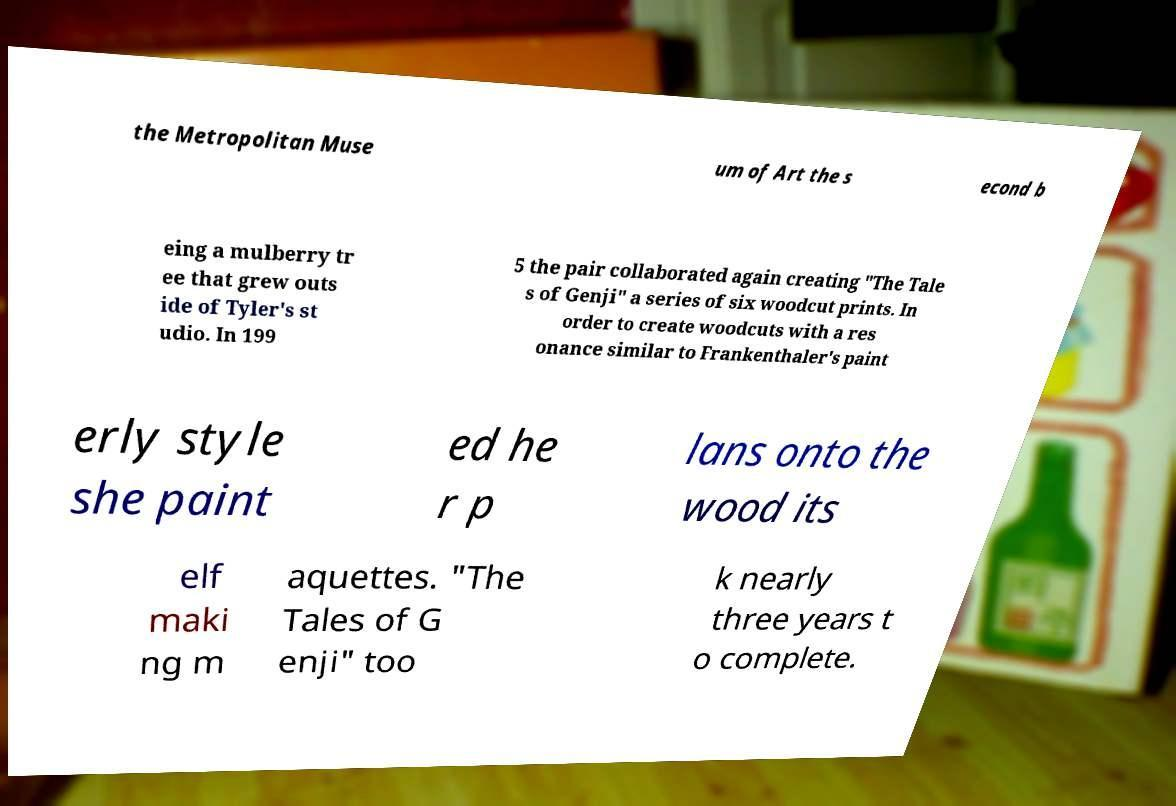What messages or text are displayed in this image? I need them in a readable, typed format. the Metropolitan Muse um of Art the s econd b eing a mulberry tr ee that grew outs ide of Tyler's st udio. In 199 5 the pair collaborated again creating "The Tale s of Genji" a series of six woodcut prints. In order to create woodcuts with a res onance similar to Frankenthaler's paint erly style she paint ed he r p lans onto the wood its elf maki ng m aquettes. "The Tales of G enji" too k nearly three years t o complete. 